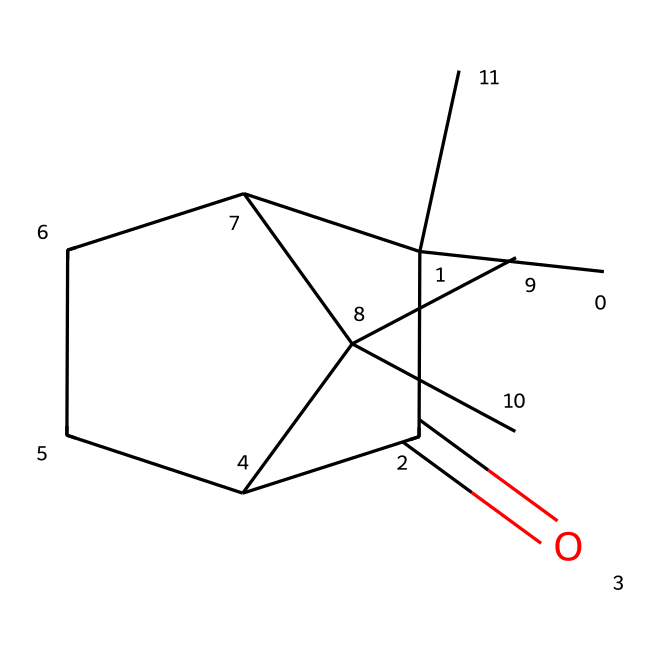What is the molecular formula of camphor? To determine the molecular formula, we can analyze the structure represented by the SMILES. By counting the carbon (C), hydrogen (H), and oxygen (O) atoms visually from the SMILES, we find there are 10 carbon atoms, 16 hydrogen atoms, and 1 oxygen atom. Therefore, the molecular formula is C10H16O.
Answer: C10H16O How many rings are present in the structure of camphor? Looking at the structure represented by the SMILES, we note that there are two ring structures (indicated by the numbers in the SMILES). Each numbered occurrence signifies the start and end of a ring. Thus, there are 2 rings in total.
Answer: 2 What functional group is present in camphor? From the structure, we can see a carbonyl group (C=O) which is characteristic of ketones. This specific feature identifies camphor’s functional group as a ketone.
Answer: ketone What is the stereochemistry of camphor? The arrangement of atoms in camphor reveals chirality due to the presence of asymmetric carbon atoms. Evaluating the structure indicates that it has one chiral center, resulting in specific stereochemical configurations (noted specifically as having a R/S designation in full stereochemical representation).
Answer: chiral What is the significance of the ketone functional group in camphor's applications? The ketone functional group in camphor is significant as it contributes to the compound's reactivity and its olfactory properties, making it suitable for use in fragrances and pharmaceuticals. The presence of the carbonyl structure influences how camphor interacts with biological receptors and its solubility properties, which are important in these applications.
Answer: pharmaceutical and fragrance applications 